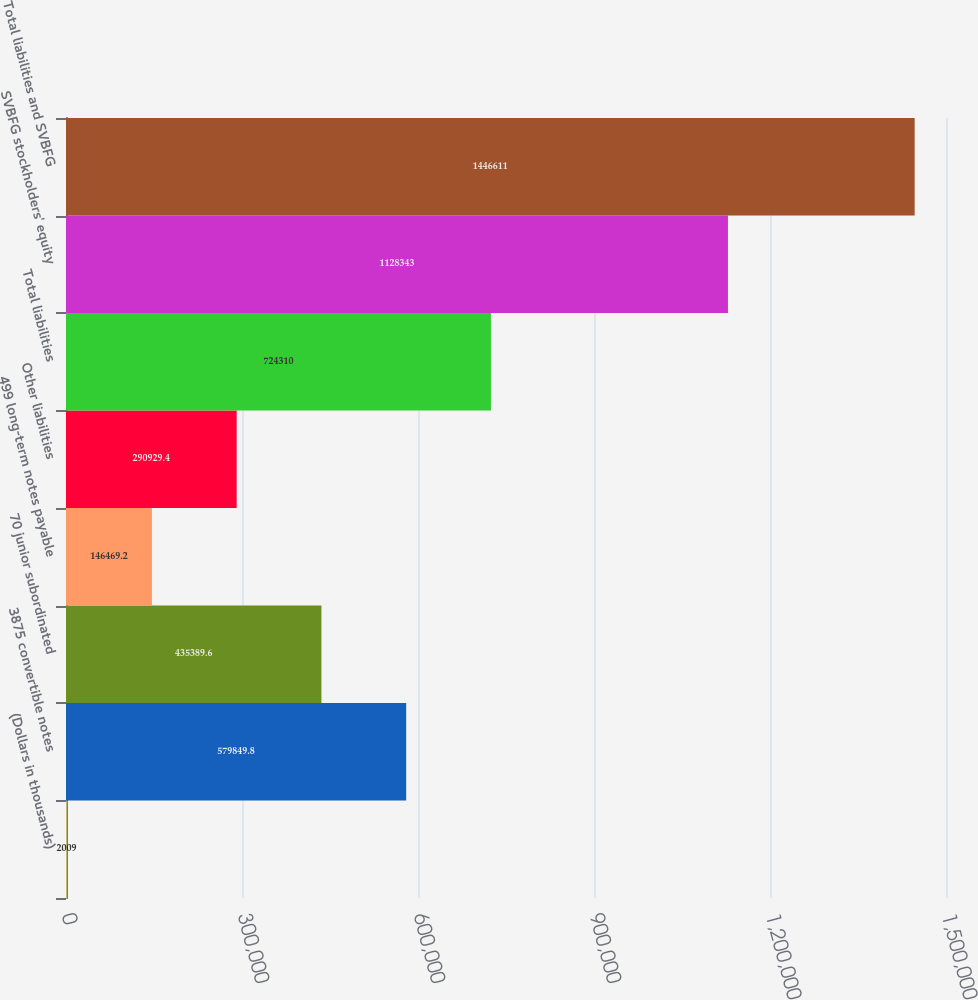Convert chart to OTSL. <chart><loc_0><loc_0><loc_500><loc_500><bar_chart><fcel>(Dollars in thousands)<fcel>3875 convertible notes<fcel>70 junior subordinated<fcel>499 long-term notes payable<fcel>Other liabilities<fcel>Total liabilities<fcel>SVBFG stockholders' equity<fcel>Total liabilities and SVBFG<nl><fcel>2009<fcel>579850<fcel>435390<fcel>146469<fcel>290929<fcel>724310<fcel>1.12834e+06<fcel>1.44661e+06<nl></chart> 